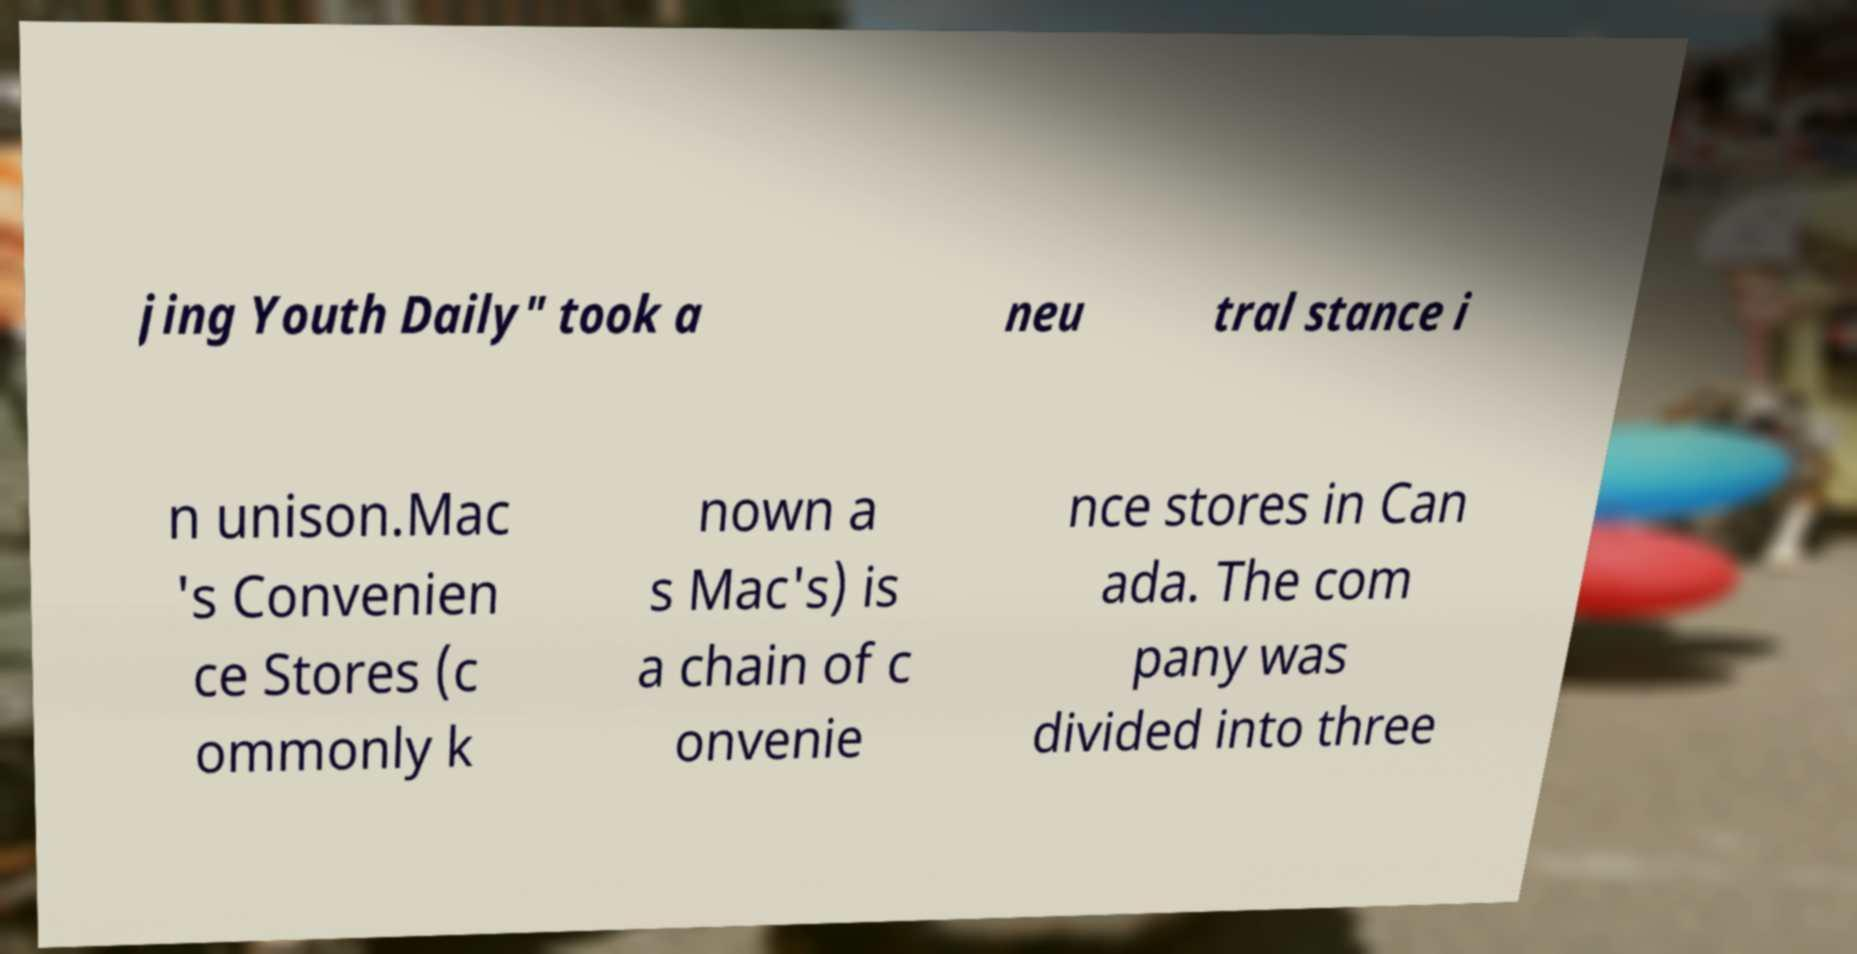Please read and relay the text visible in this image. What does it say? jing Youth Daily" took a neu tral stance i n unison.Mac 's Convenien ce Stores (c ommonly k nown a s Mac's) is a chain of c onvenie nce stores in Can ada. The com pany was divided into three 